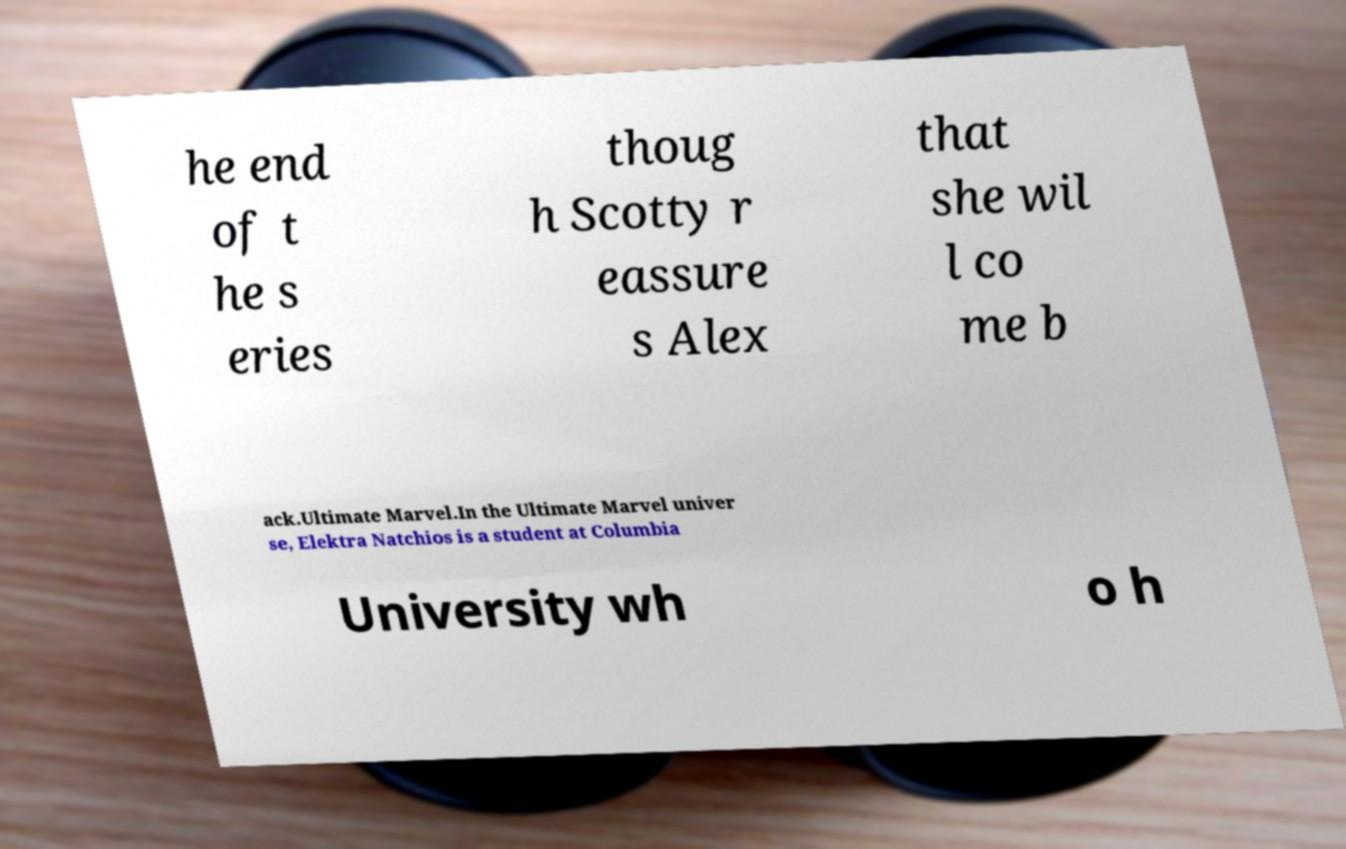I need the written content from this picture converted into text. Can you do that? he end of t he s eries thoug h Scotty r eassure s Alex that she wil l co me b ack.Ultimate Marvel.In the Ultimate Marvel univer se, Elektra Natchios is a student at Columbia University wh o h 